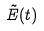<formula> <loc_0><loc_0><loc_500><loc_500>\tilde { E } ( t )</formula> 